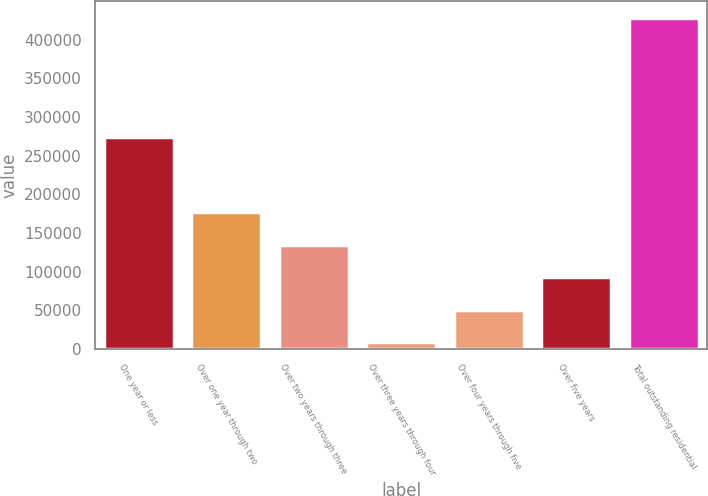Convert chart to OTSL. <chart><loc_0><loc_0><loc_500><loc_500><bar_chart><fcel>One year or less<fcel>Over one year through two<fcel>Over two years through three<fcel>Over three years through four<fcel>Over four years through five<fcel>Over five years<fcel>Total outstanding residential<nl><fcel>273639<fcel>176554<fcel>134630<fcel>8858<fcel>50781.9<fcel>92705.8<fcel>428097<nl></chart> 